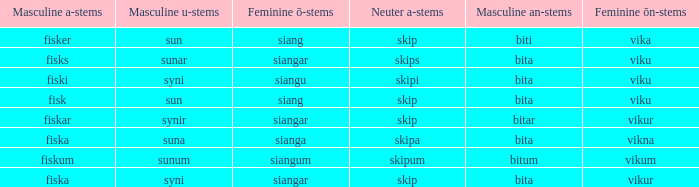What is the an-stem for the word which has an ö-stems of siangar and an u-stem ending of syni? Bita. 